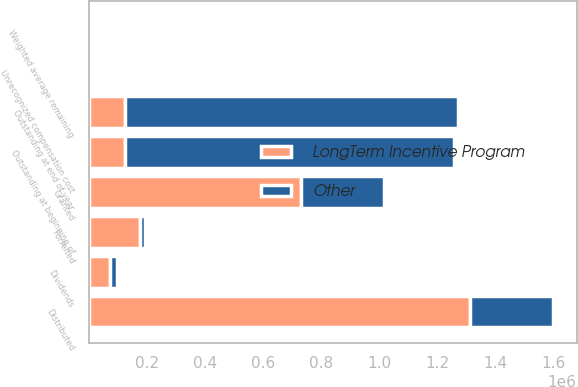<chart> <loc_0><loc_0><loc_500><loc_500><stacked_bar_chart><ecel><fcel>Outstanding at beginning of<fcel>Granted<fcel>Dividends<fcel>Forfeited<fcel>Distributed<fcel>Outstanding at end of year<fcel>Unrecognized compensation cost<fcel>Weighted average remaining<nl><fcel>LongTerm Incentive Program<fcel>125186<fcel>729603<fcel>72387<fcel>177986<fcel>1.31378e+06<fcel>125186<fcel>94<fcel>1.7<nl><fcel>Other<fcel>1.13293e+06<fcel>288600<fcel>25833<fcel>13962<fcel>286303<fcel>1.1471e+06<fcel>41<fcel>2.3<nl></chart> 